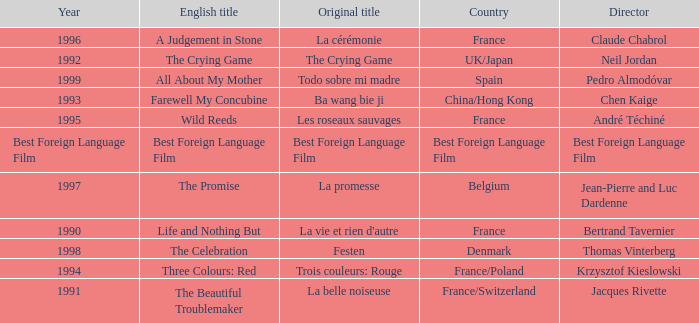Who is the Director of the Original title of The Crying Game? Neil Jordan. 